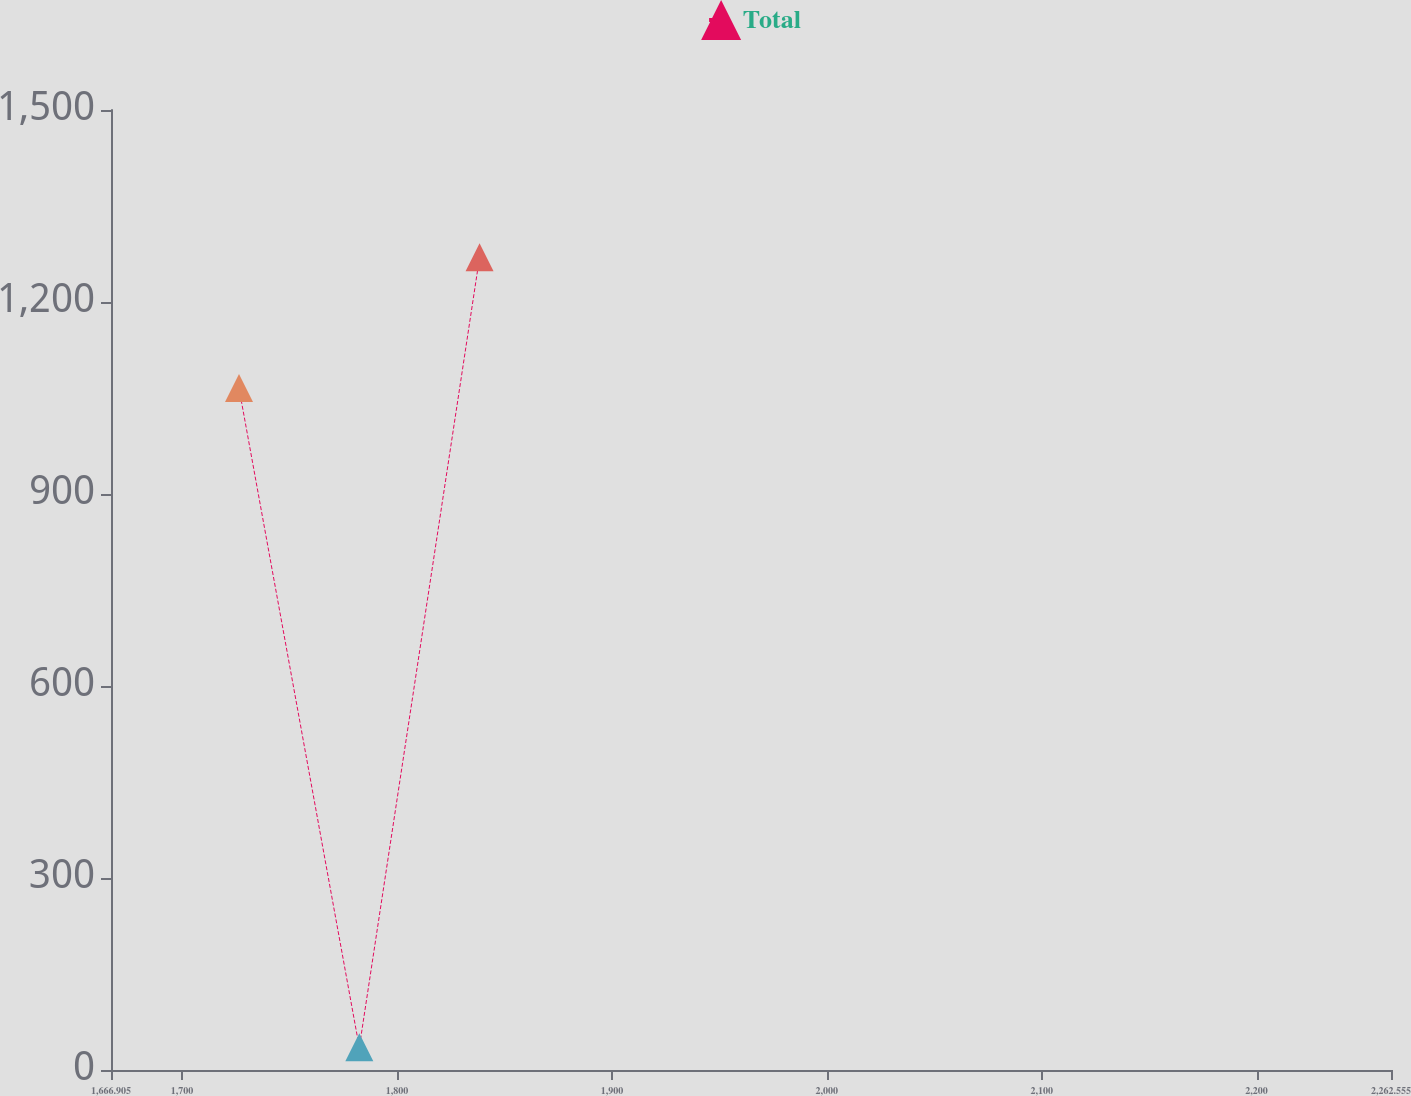Convert chart to OTSL. <chart><loc_0><loc_0><loc_500><loc_500><line_chart><ecel><fcel>Total<nl><fcel>1726.47<fcel>1065.44<nl><fcel>1782.45<fcel>35.36<nl><fcel>1838.43<fcel>1270.07<nl><fcel>2266.14<fcel>1393.56<nl><fcel>2322.12<fcel>765.3<nl></chart> 